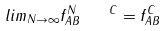Convert formula to latex. <formula><loc_0><loc_0><loc_500><loc_500>l i m _ { N \to \infty } f _ { A B } ^ { N \quad C } = f _ { A B } ^ { C }</formula> 